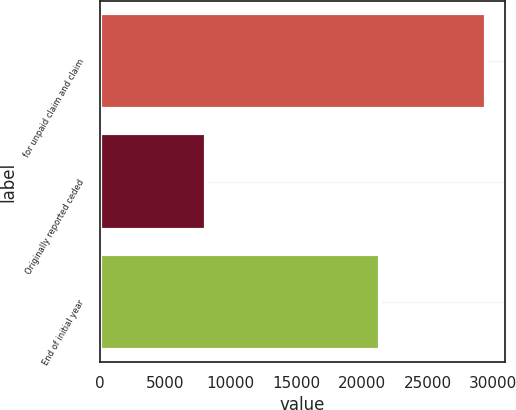Convert chart. <chart><loc_0><loc_0><loc_500><loc_500><bar_chart><fcel>for unpaid claim and claim<fcel>Originally reported ceded<fcel>End of initial year<nl><fcel>29459<fcel>8078<fcel>21381<nl></chart> 